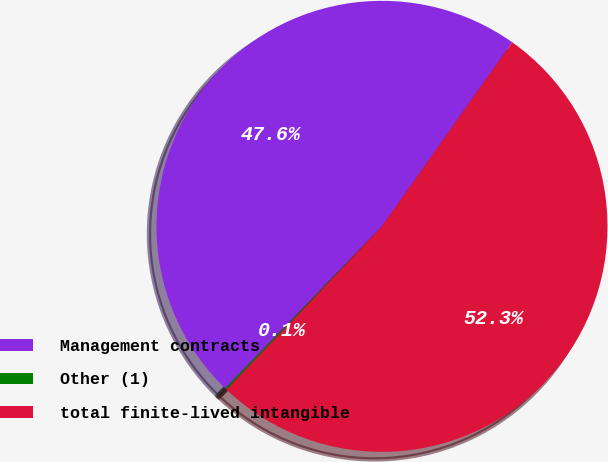Convert chart to OTSL. <chart><loc_0><loc_0><loc_500><loc_500><pie_chart><fcel>Management contracts<fcel>Other (1)<fcel>total finite-lived intangible<nl><fcel>47.56%<fcel>0.13%<fcel>52.31%<nl></chart> 